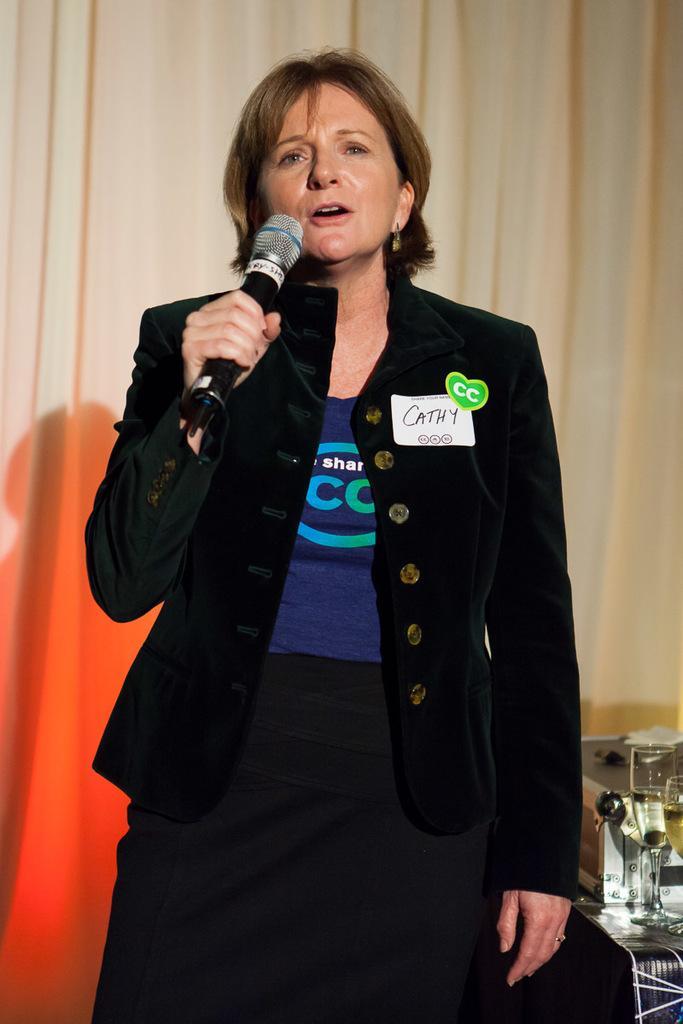Describe this image in one or two sentences. In the center we can see one woman holding microphone. And coming to back we can see curtain. 